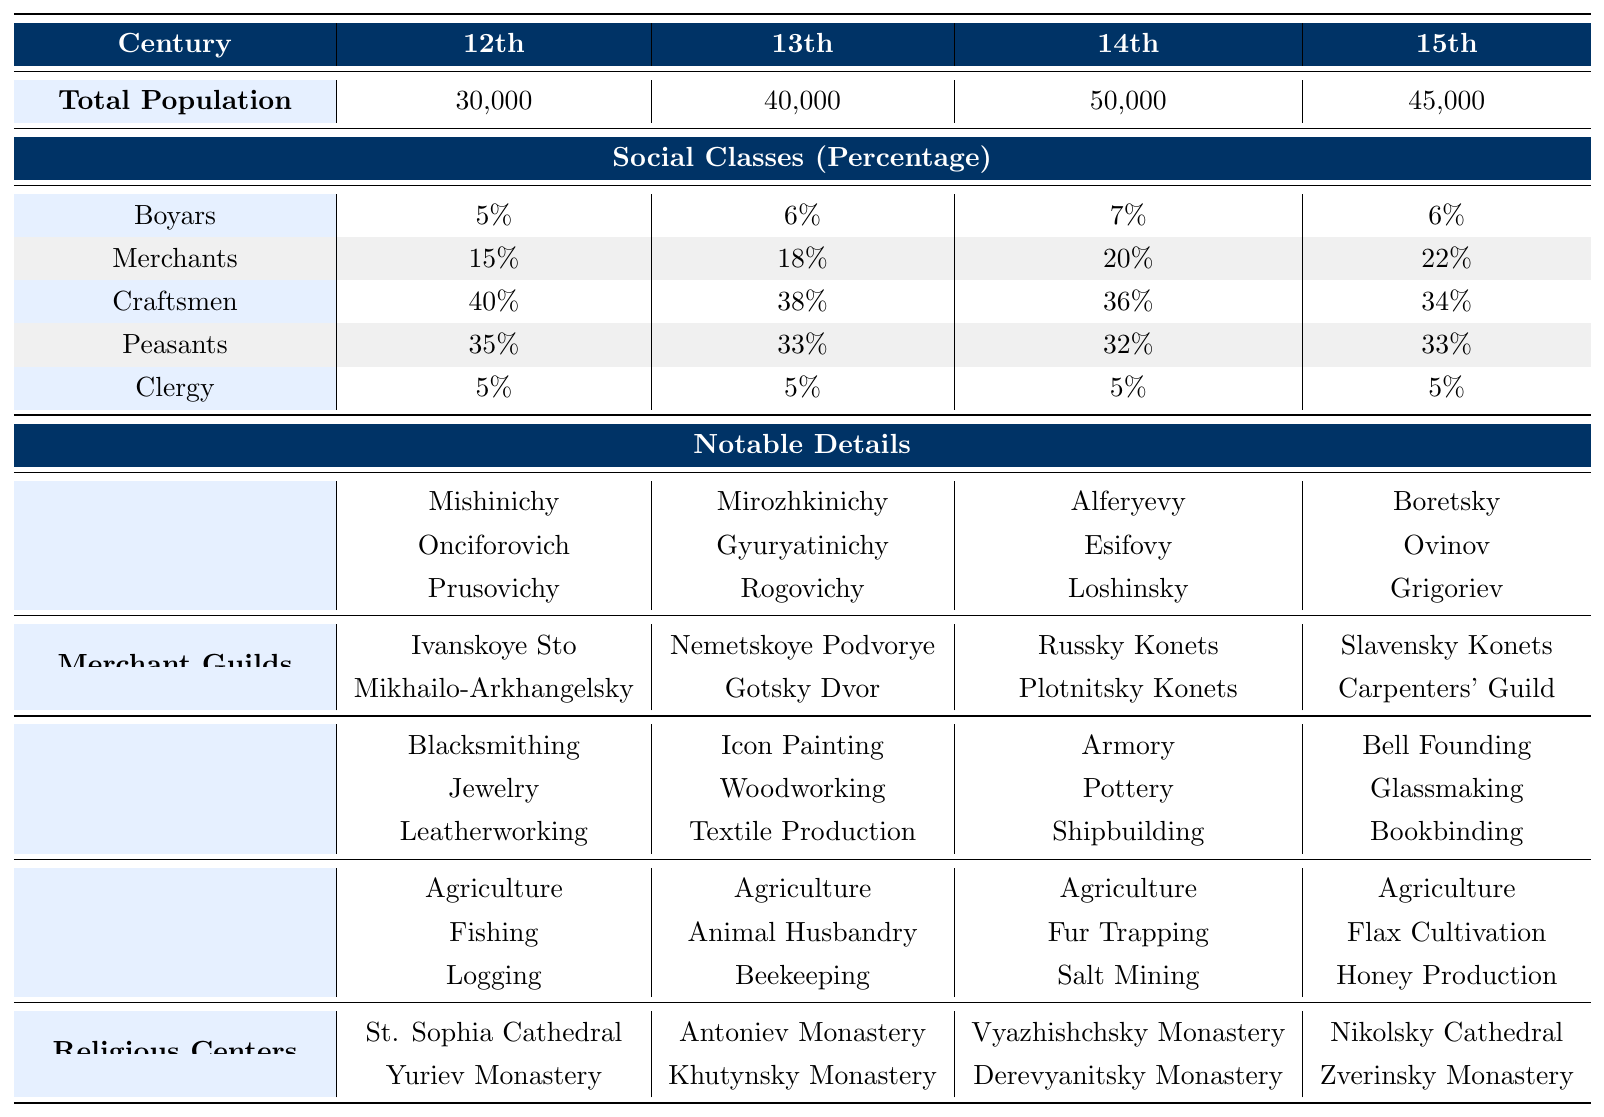What was the total population of Veliky Novgorod in the 14th century? The table states that the total population for the 14th century is listed as 50,000.
Answer: 50,000 What percentage of the population were craftsmen in the 12th century? The table shows that craftsmen made up 40% of the population in the 12th century.
Answer: 40% Which social class had the highest percentage in the 13th century? By examining the percentages, craftsmen at 38% had the highest percentage in the 13th century compared to the other classes.
Answer: Craftsmen What was the change in the total population from the 12th century to the 15th century? The total population in the 12th century was 30,000 and in the 15th century was 45,000. Therefore, the change is 45,000 - 30,000 = 15,000.
Answer: 15,000 How many notable families are listed for the boyars in the 14th century? The table lists three notable families for the boyars in the 14th century: Alferyevy, Esifovy, and Loshinsky.
Answer: 3 What was the average percentage of clergy across all four centuries? To find the average, add the percentages of clergy (5% + 5% + 5% + 5% = 20%) and divide by the number of centuries (4). Thus, the average is 20% / 4 = 5%.
Answer: 5% Which century saw the largest increase in the percentage of merchants from the previous century? By reviewing the percentages, from the 12th (15%) to the 13th century (18%), there was an increase of 3%. From the 13th (18%) to the 14th (20%), the increase was 2%. The largest increase is between the 12th and 13th centuries.
Answer: 12th to 13th Is it true that the percentage of peasants increased from the 12th to the 14th century? Comparing the percentages, in the 12th century, it was 35%, and in the 14th century, it was 32%, showing a decrease. Therefore, the statement is false.
Answer: No What is the total number of notable families mentioned for the boyars from the 12th to the 15th century combined? The notable families listed are 3 in the 12th (Mishinichy, Onciforovich, Prusovichy), 3 in the 13th (Mirozhkinichy, Gyuryatinichy, Rogovichy), 3 in the 14th (Alferyevy, Esifovy, Loshinsky), and 3 in the 15th (Boretsky, Ovinov, Grigoriev). Adding these gives 3 + 3 + 3 + 3 = 12.
Answer: 12 Which social class had the least percentage change from the 12th to the 15th century? Examining the percentages, the clergy remained at 5% for all centuries, meaning there was no change, whereas others had varying changes. Thus, clergy had no percentage change.
Answer: Clergy 